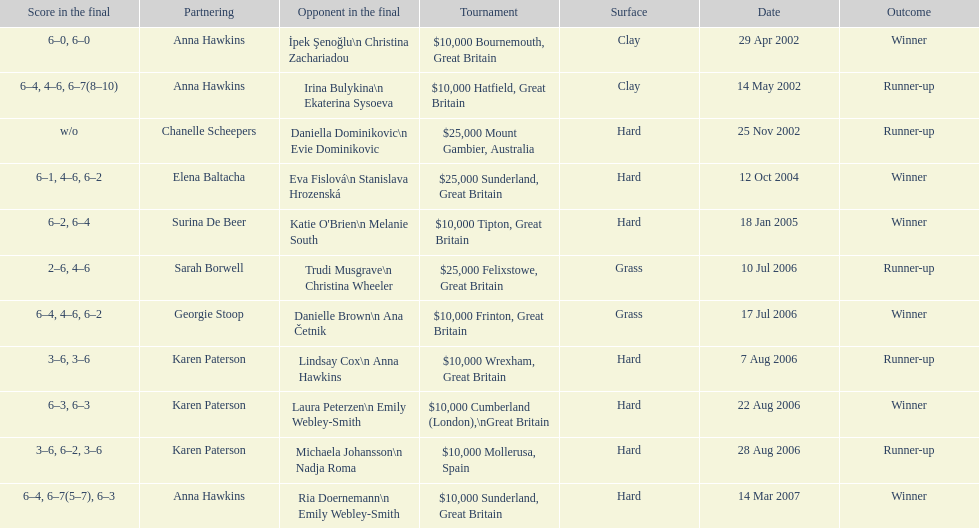Would you be able to parse every entry in this table? {'header': ['Score in the final', 'Partnering', 'Opponent in the final', 'Tournament', 'Surface', 'Date', 'Outcome'], 'rows': [['6–0, 6–0', 'Anna Hawkins', 'İpek Şenoğlu\\n Christina Zachariadou', '$10,000 Bournemouth, Great Britain', 'Clay', '29 Apr 2002', 'Winner'], ['6–4, 4–6, 6–7(8–10)', 'Anna Hawkins', 'Irina Bulykina\\n Ekaterina Sysoeva', '$10,000 Hatfield, Great Britain', 'Clay', '14 May 2002', 'Runner-up'], ['w/o', 'Chanelle Scheepers', 'Daniella Dominikovic\\n Evie Dominikovic', '$25,000 Mount Gambier, Australia', 'Hard', '25 Nov 2002', 'Runner-up'], ['6–1, 4–6, 6–2', 'Elena Baltacha', 'Eva Fislová\\n Stanislava Hrozenská', '$25,000 Sunderland, Great Britain', 'Hard', '12 Oct 2004', 'Winner'], ['6–2, 6–4', 'Surina De Beer', "Katie O'Brien\\n Melanie South", '$10,000 Tipton, Great Britain', 'Hard', '18 Jan 2005', 'Winner'], ['2–6, 4–6', 'Sarah Borwell', 'Trudi Musgrave\\n Christina Wheeler', '$25,000 Felixstowe, Great Britain', 'Grass', '10 Jul 2006', 'Runner-up'], ['6–4, 4–6, 6–2', 'Georgie Stoop', 'Danielle Brown\\n Ana Četnik', '$10,000 Frinton, Great Britain', 'Grass', '17 Jul 2006', 'Winner'], ['3–6, 3–6', 'Karen Paterson', 'Lindsay Cox\\n Anna Hawkins', '$10,000 Wrexham, Great Britain', 'Hard', '7 Aug 2006', 'Runner-up'], ['6–3, 6–3', 'Karen Paterson', 'Laura Peterzen\\n Emily Webley-Smith', '$10,000 Cumberland (London),\\nGreat Britain', 'Hard', '22 Aug 2006', 'Winner'], ['3–6, 6–2, 3–6', 'Karen Paterson', 'Michaela Johansson\\n Nadja Roma', '$10,000 Mollerusa, Spain', 'Hard', '28 Aug 2006', 'Runner-up'], ['6–4, 6–7(5–7), 6–3', 'Anna Hawkins', 'Ria Doernemann\\n Emily Webley-Smith', '$10,000 Sunderland, Great Britain', 'Hard', '14 Mar 2007', 'Winner']]} How many tournaments has jane o'donoghue competed in? 11. 